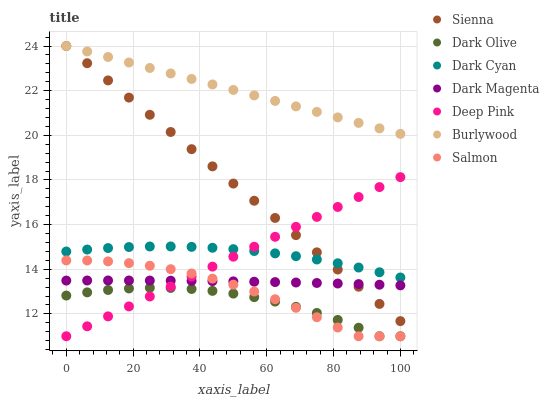Does Dark Olive have the minimum area under the curve?
Answer yes or no. Yes. Does Burlywood have the maximum area under the curve?
Answer yes or no. Yes. Does Dark Magenta have the minimum area under the curve?
Answer yes or no. No. Does Dark Magenta have the maximum area under the curve?
Answer yes or no. No. Is Deep Pink the smoothest?
Answer yes or no. Yes. Is Salmon the roughest?
Answer yes or no. Yes. Is Dark Magenta the smoothest?
Answer yes or no. No. Is Dark Magenta the roughest?
Answer yes or no. No. Does Deep Pink have the lowest value?
Answer yes or no. Yes. Does Dark Magenta have the lowest value?
Answer yes or no. No. Does Sienna have the highest value?
Answer yes or no. Yes. Does Dark Magenta have the highest value?
Answer yes or no. No. Is Salmon less than Sienna?
Answer yes or no. Yes. Is Dark Cyan greater than Dark Magenta?
Answer yes or no. Yes. Does Deep Pink intersect Dark Olive?
Answer yes or no. Yes. Is Deep Pink less than Dark Olive?
Answer yes or no. No. Is Deep Pink greater than Dark Olive?
Answer yes or no. No. Does Salmon intersect Sienna?
Answer yes or no. No. 